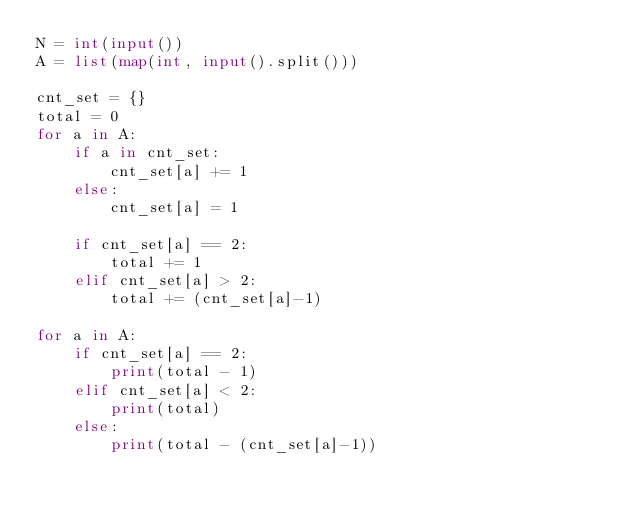<code> <loc_0><loc_0><loc_500><loc_500><_Python_>N = int(input())
A = list(map(int, input().split()))

cnt_set = {}
total = 0
for a in A:
    if a in cnt_set:
        cnt_set[a] += 1
    else:
        cnt_set[a] = 1

    if cnt_set[a] == 2:
        total += 1
    elif cnt_set[a] > 2:
        total += (cnt_set[a]-1)

for a in A:
    if cnt_set[a] == 2:
        print(total - 1)
    elif cnt_set[a] < 2:
        print(total)
    else:
        print(total - (cnt_set[a]-1))
</code> 